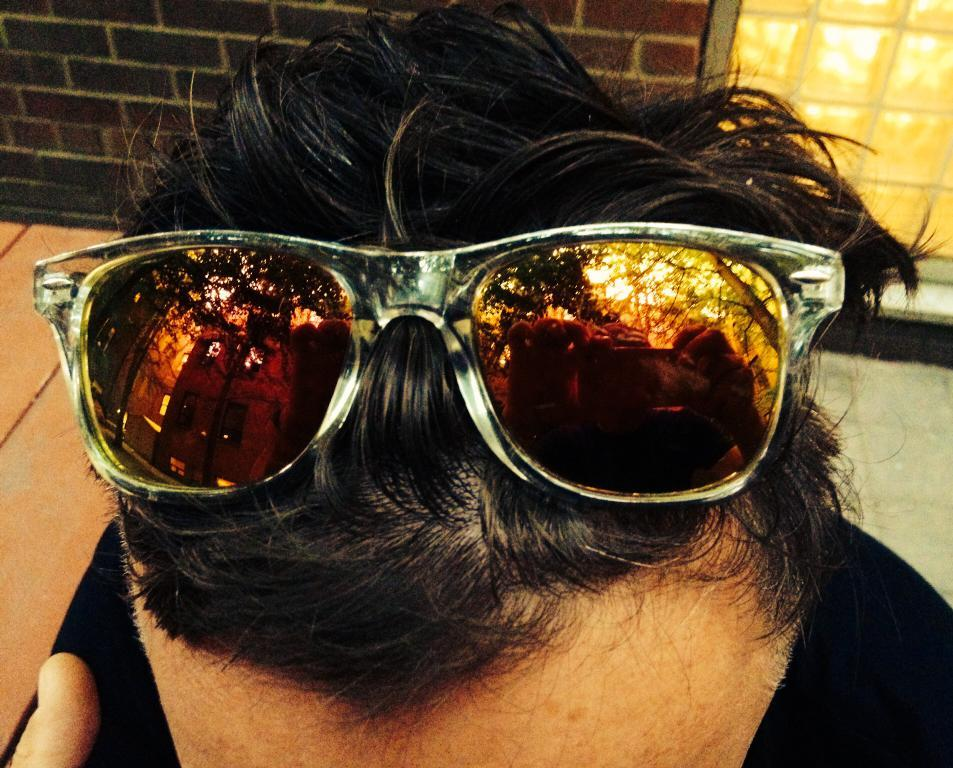What is the main subject of the image? There is a person in the image. What is the person wearing on their hair? The person is wearing goggles on their hair. What can be seen in the background of the image? There is a brick wall and a window in the background of the image. What type of soda is the person holding in the image? There is no soda present in the image; the person is wearing goggles on their hair. Can you see any insects in the image? There are no insects visible in the image; it features a person with goggles on their hair and a brick wall and window in the background. 